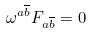Convert formula to latex. <formula><loc_0><loc_0><loc_500><loc_500>\omega ^ { a \overline { b } } F _ { a \overline { b } } = 0</formula> 